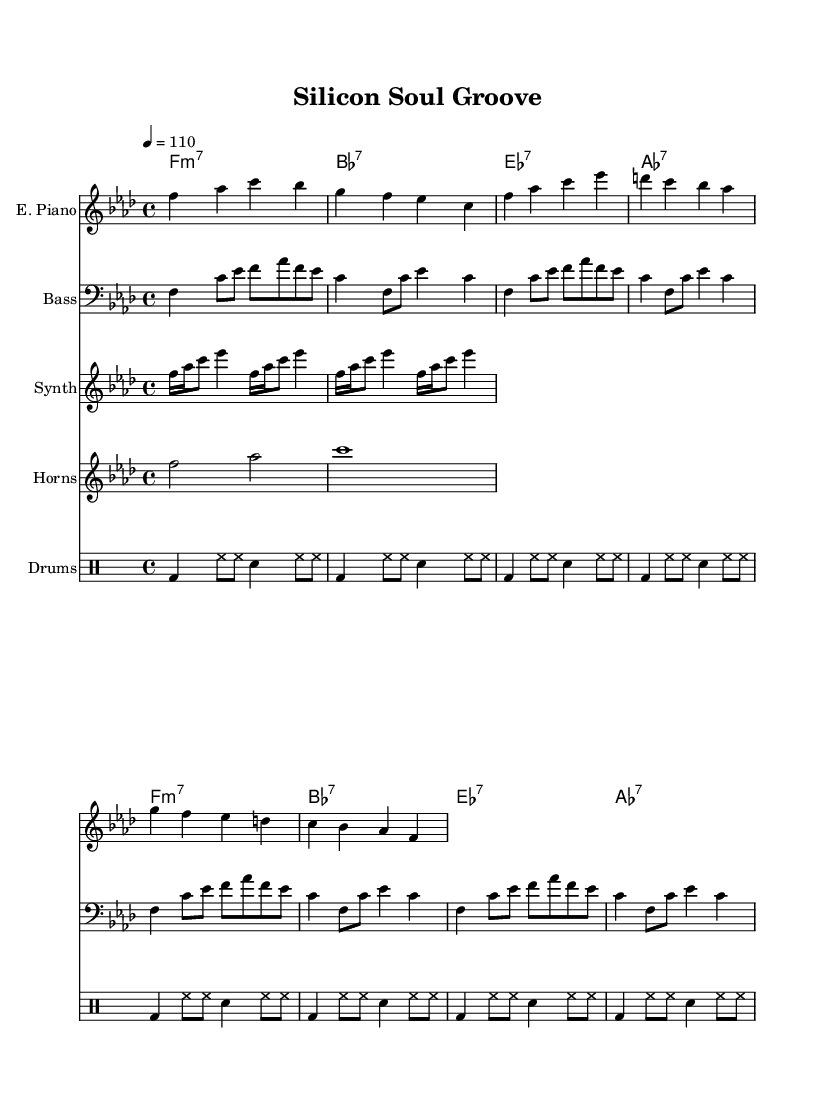What is the key signature of this music? The key signature indicated in the global settings is F minor, which often includes four flats (B♭, E♭, A♭, and D♭) in the key signature.
Answer: F minor What is the time signature of this music? The time signature present in the global settings is 4/4, which indicates four beats per measure and is one of the most common time signatures in music.
Answer: 4/4 What is the tempo of this piece? The tempo marking in the global settings specifies a quarter note (4) equals 110 beats per minute, indicating the speed at which the piece should be played.
Answer: 110 How many bars does the bass pattern repeat? The bass pattern in the provided score is indicated to repeat four times, as seen in the \repeat unfold command.
Answer: 4 What chord follows F minor 7 in the intro? The chord progression in the intro includes F minor 7 followed by B♭7, which can be found in the chord names section corresponding to the intro measures.
Answer: B♭7 Which instrument plays the synth riff? The synth riff is played by the "Synth," as indicated by the instrument name attached to that staff in the score.
Answer: Synth What type of rhythm does the drum pattern primarily showcase? The drum pattern primarily showcases a combination of bass drum, hi-hat, and snare, which is structured with a consistent alternating rhythm across the measures.
Answer: Funky 